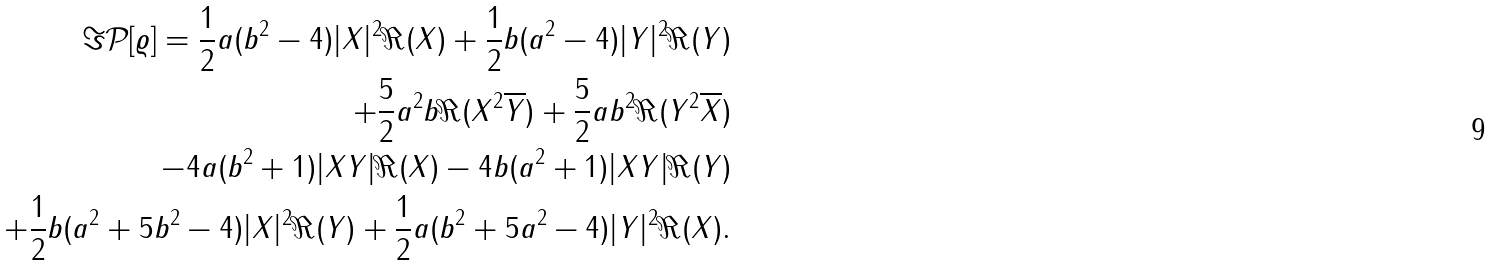Convert formula to latex. <formula><loc_0><loc_0><loc_500><loc_500>\Im \mathcal { P } [ \varrho ] = \frac { 1 } { 2 } a ( b ^ { 2 } - 4 ) | X | ^ { 2 } \Re ( X ) + \frac { 1 } { 2 } b ( a ^ { 2 } - 4 ) | Y | ^ { 2 } \Re ( Y ) \\ + \frac { 5 } { 2 } a ^ { 2 } b \Re ( X ^ { 2 } \overline { Y } ) + \frac { 5 } { 2 } a b ^ { 2 } \Re ( Y ^ { 2 } \overline { X } ) \\ - 4 a ( b ^ { 2 } + 1 ) | X Y | \Re ( X ) - 4 b ( a ^ { 2 } + 1 ) | X Y | \Re ( Y ) \\ + \frac { 1 } { 2 } b ( a ^ { 2 } + 5 b ^ { 2 } - 4 ) | X | ^ { 2 } \Re ( Y ) + \frac { 1 } { 2 } a ( b ^ { 2 } + 5 a ^ { 2 } - 4 ) | Y | ^ { 2 } \Re ( X ) .</formula> 